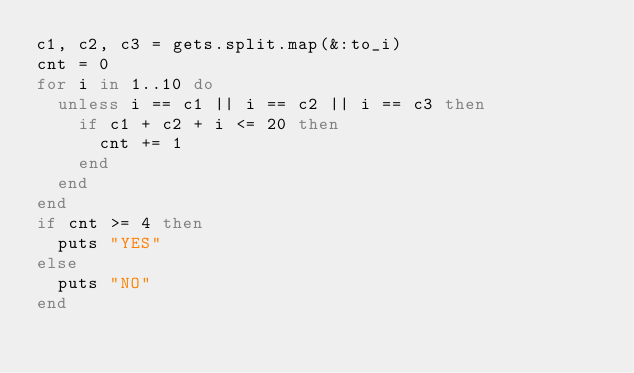Convert code to text. <code><loc_0><loc_0><loc_500><loc_500><_Ruby_>c1, c2, c3 = gets.split.map(&:to_i)
cnt = 0
for i in 1..10 do
  unless i == c1 || i == c2 || i == c3 then
  	if c1 + c2 + i <= 20 then
  	  cnt += 1
    end
  end
end
if cnt >= 4 then
  puts "YES"
else
  puts "NO"
end</code> 